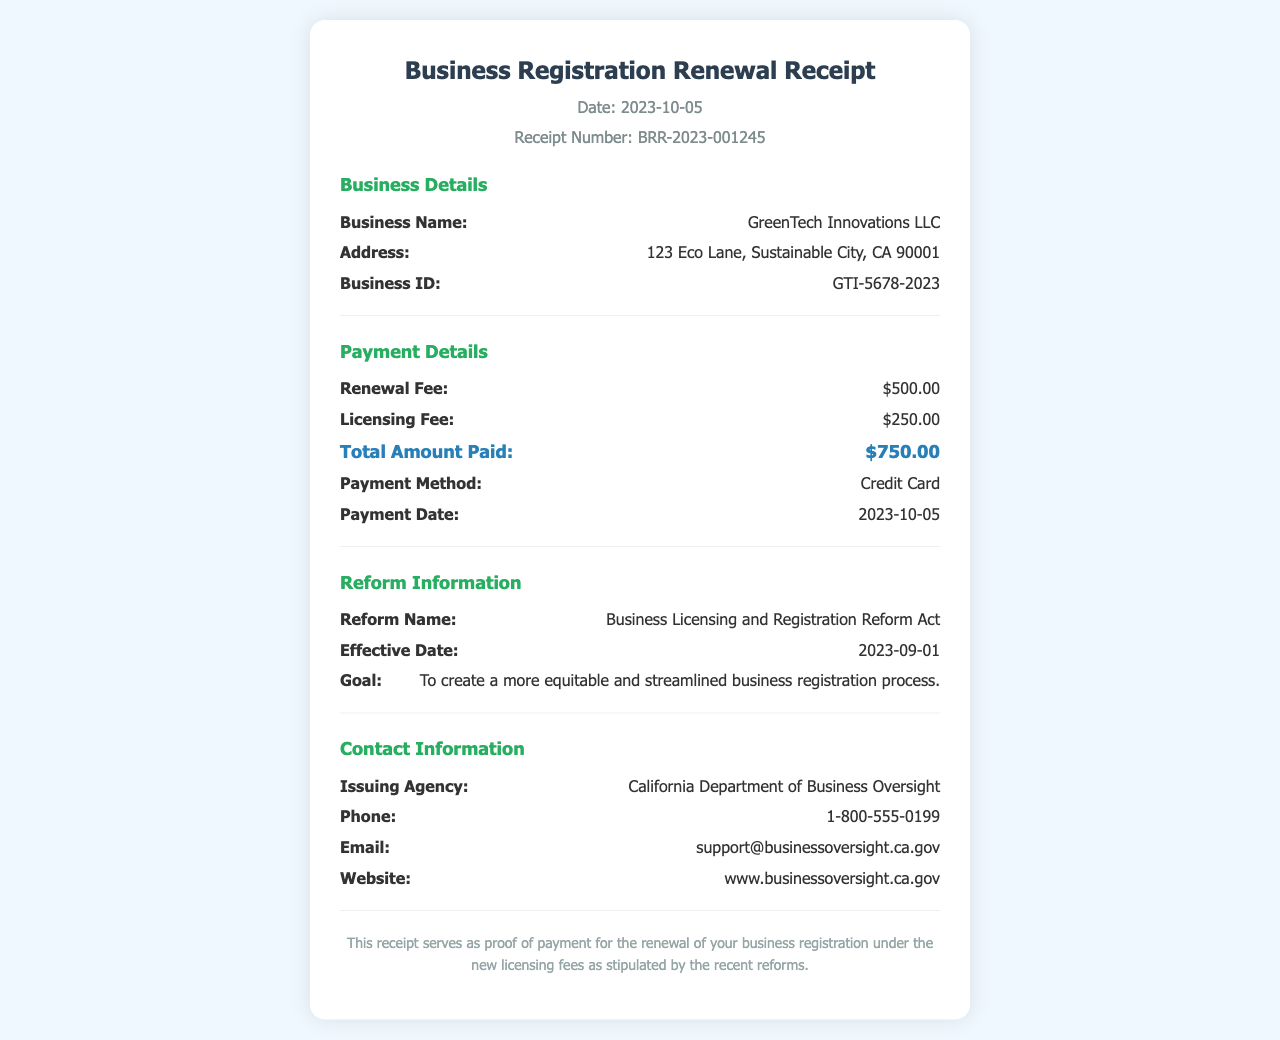what is the receipt number? The receipt number is a unique identifier for the transaction, found in the header of the document.
Answer: BRR-2023-001245 what is the total amount paid? The total amount paid is located in the payment details section, representing the cumulative fees.
Answer: $750.00 when was the payment dated? The payment date indicates when the payment was processed, as specified in the payment details.
Answer: 2023-10-05 what is the business name? The business name identifies the entity as listed in the business details section of the receipt.
Answer: GreenTech Innovations LLC what is the goal of the reform? The goal outlines the purpose of the reform, summarizing its intent for business registration.
Answer: To create a more equitable and streamlined business registration process what is the licensing fee? The licensing fee is detailed under payment details and represents part of the total payment amount.
Answer: $250.00 which agency issued the receipt? The issuing agency provides authority and legitimacy to the receipt, found in the contact information section.
Answer: California Department of Business Oversight what reform act is mentioned? The reform act names the legislative change that affects the business registration fees and processes.
Answer: Business Licensing and Registration Reform Act what is the effective date of the reform? The effective date shows when the new regulations came into force, relevant to the business registration.
Answer: 2023-09-01 